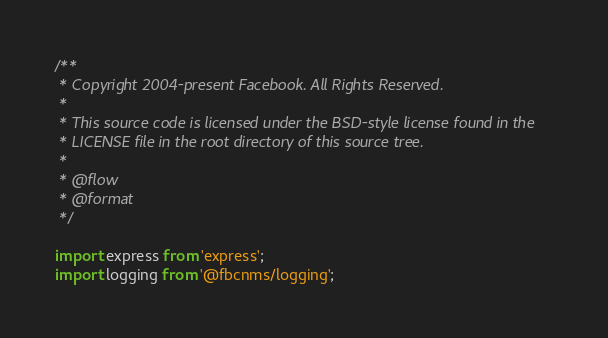<code> <loc_0><loc_0><loc_500><loc_500><_JavaScript_>/**
 * Copyright 2004-present Facebook. All Rights Reserved.
 *
 * This source code is licensed under the BSD-style license found in the
 * LICENSE file in the root directory of this source tree.
 *
 * @flow
 * @format
 */

import express from 'express';
import logging from '@fbcnms/logging';
</code> 